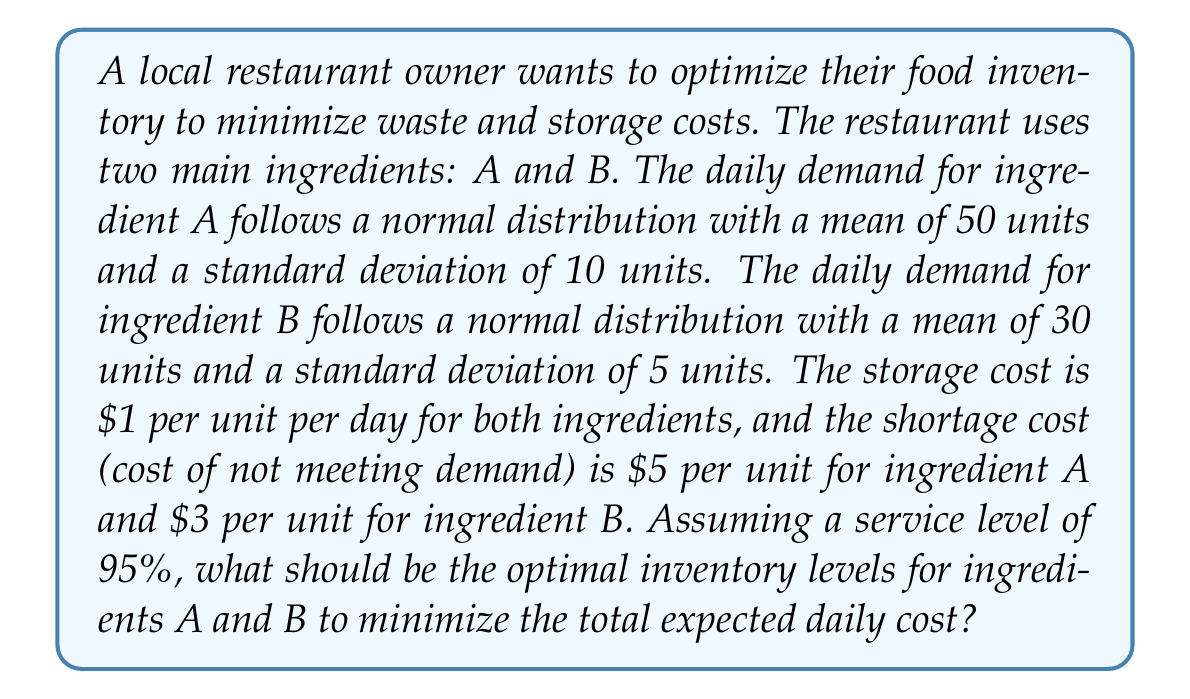Could you help me with this problem? To solve this problem, we need to use the newsvendor model for each ingredient. The optimal inventory level for each ingredient is given by the formula:

$$ Q^* = \mu + z \sigma $$

Where:
$Q^*$ is the optimal inventory level
$\mu$ is the mean demand
$\sigma$ is the standard deviation of demand
$z$ is the z-score corresponding to the desired service level

For a 95% service level, $z = 1.645$ (from standard normal distribution tables)

Step 1: Calculate the optimal inventory level for ingredient A
$\mu_A = 50$, $\sigma_A = 10$
$Q^*_A = 50 + 1.645 \times 10 = 66.45$ units

Step 2: Calculate the optimal inventory level for ingredient B
$\mu_B = 30$, $\sigma_B = 5$
$Q^*_B = 30 + 1.645 \times 5 = 38.225$ units

Step 3: Calculate the expected daily cost
The expected daily cost consists of two components: expected holding cost and expected shortage cost.

For ingredient A:
Expected holding cost = $1 \times (66.45 - 50) = $16.45
Expected shortage cost = $5 \times 0.05 \times 10 \times 0.399 = $0.9975
(0.399 is the expected shortage for a standard normal distribution with 95% service level)

Total expected daily cost for A = $16.45 + $0.9975 = $17.4475

For ingredient B:
Expected holding cost = $1 \times (38.225 - 30) = $8.225
Expected shortage cost = $3 \times 0.05 \times 5 \times 0.399 = $0.29925

Total expected daily cost for B = $8.225 + $0.29925 = $8.52425

Total expected daily cost for both ingredients = $17.4475 + $8.52425 = $25.97175
Answer: The optimal inventory levels are 67 units for ingredient A and 39 units for ingredient B (rounded up to the nearest integer). The total expected daily cost is approximately $25.97. 